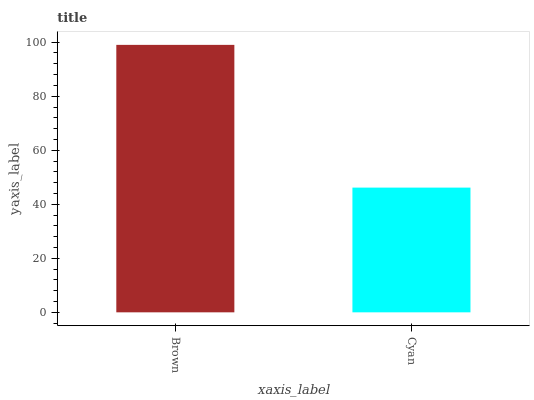Is Cyan the minimum?
Answer yes or no. Yes. Is Brown the maximum?
Answer yes or no. Yes. Is Cyan the maximum?
Answer yes or no. No. Is Brown greater than Cyan?
Answer yes or no. Yes. Is Cyan less than Brown?
Answer yes or no. Yes. Is Cyan greater than Brown?
Answer yes or no. No. Is Brown less than Cyan?
Answer yes or no. No. Is Brown the high median?
Answer yes or no. Yes. Is Cyan the low median?
Answer yes or no. Yes. Is Cyan the high median?
Answer yes or no. No. Is Brown the low median?
Answer yes or no. No. 